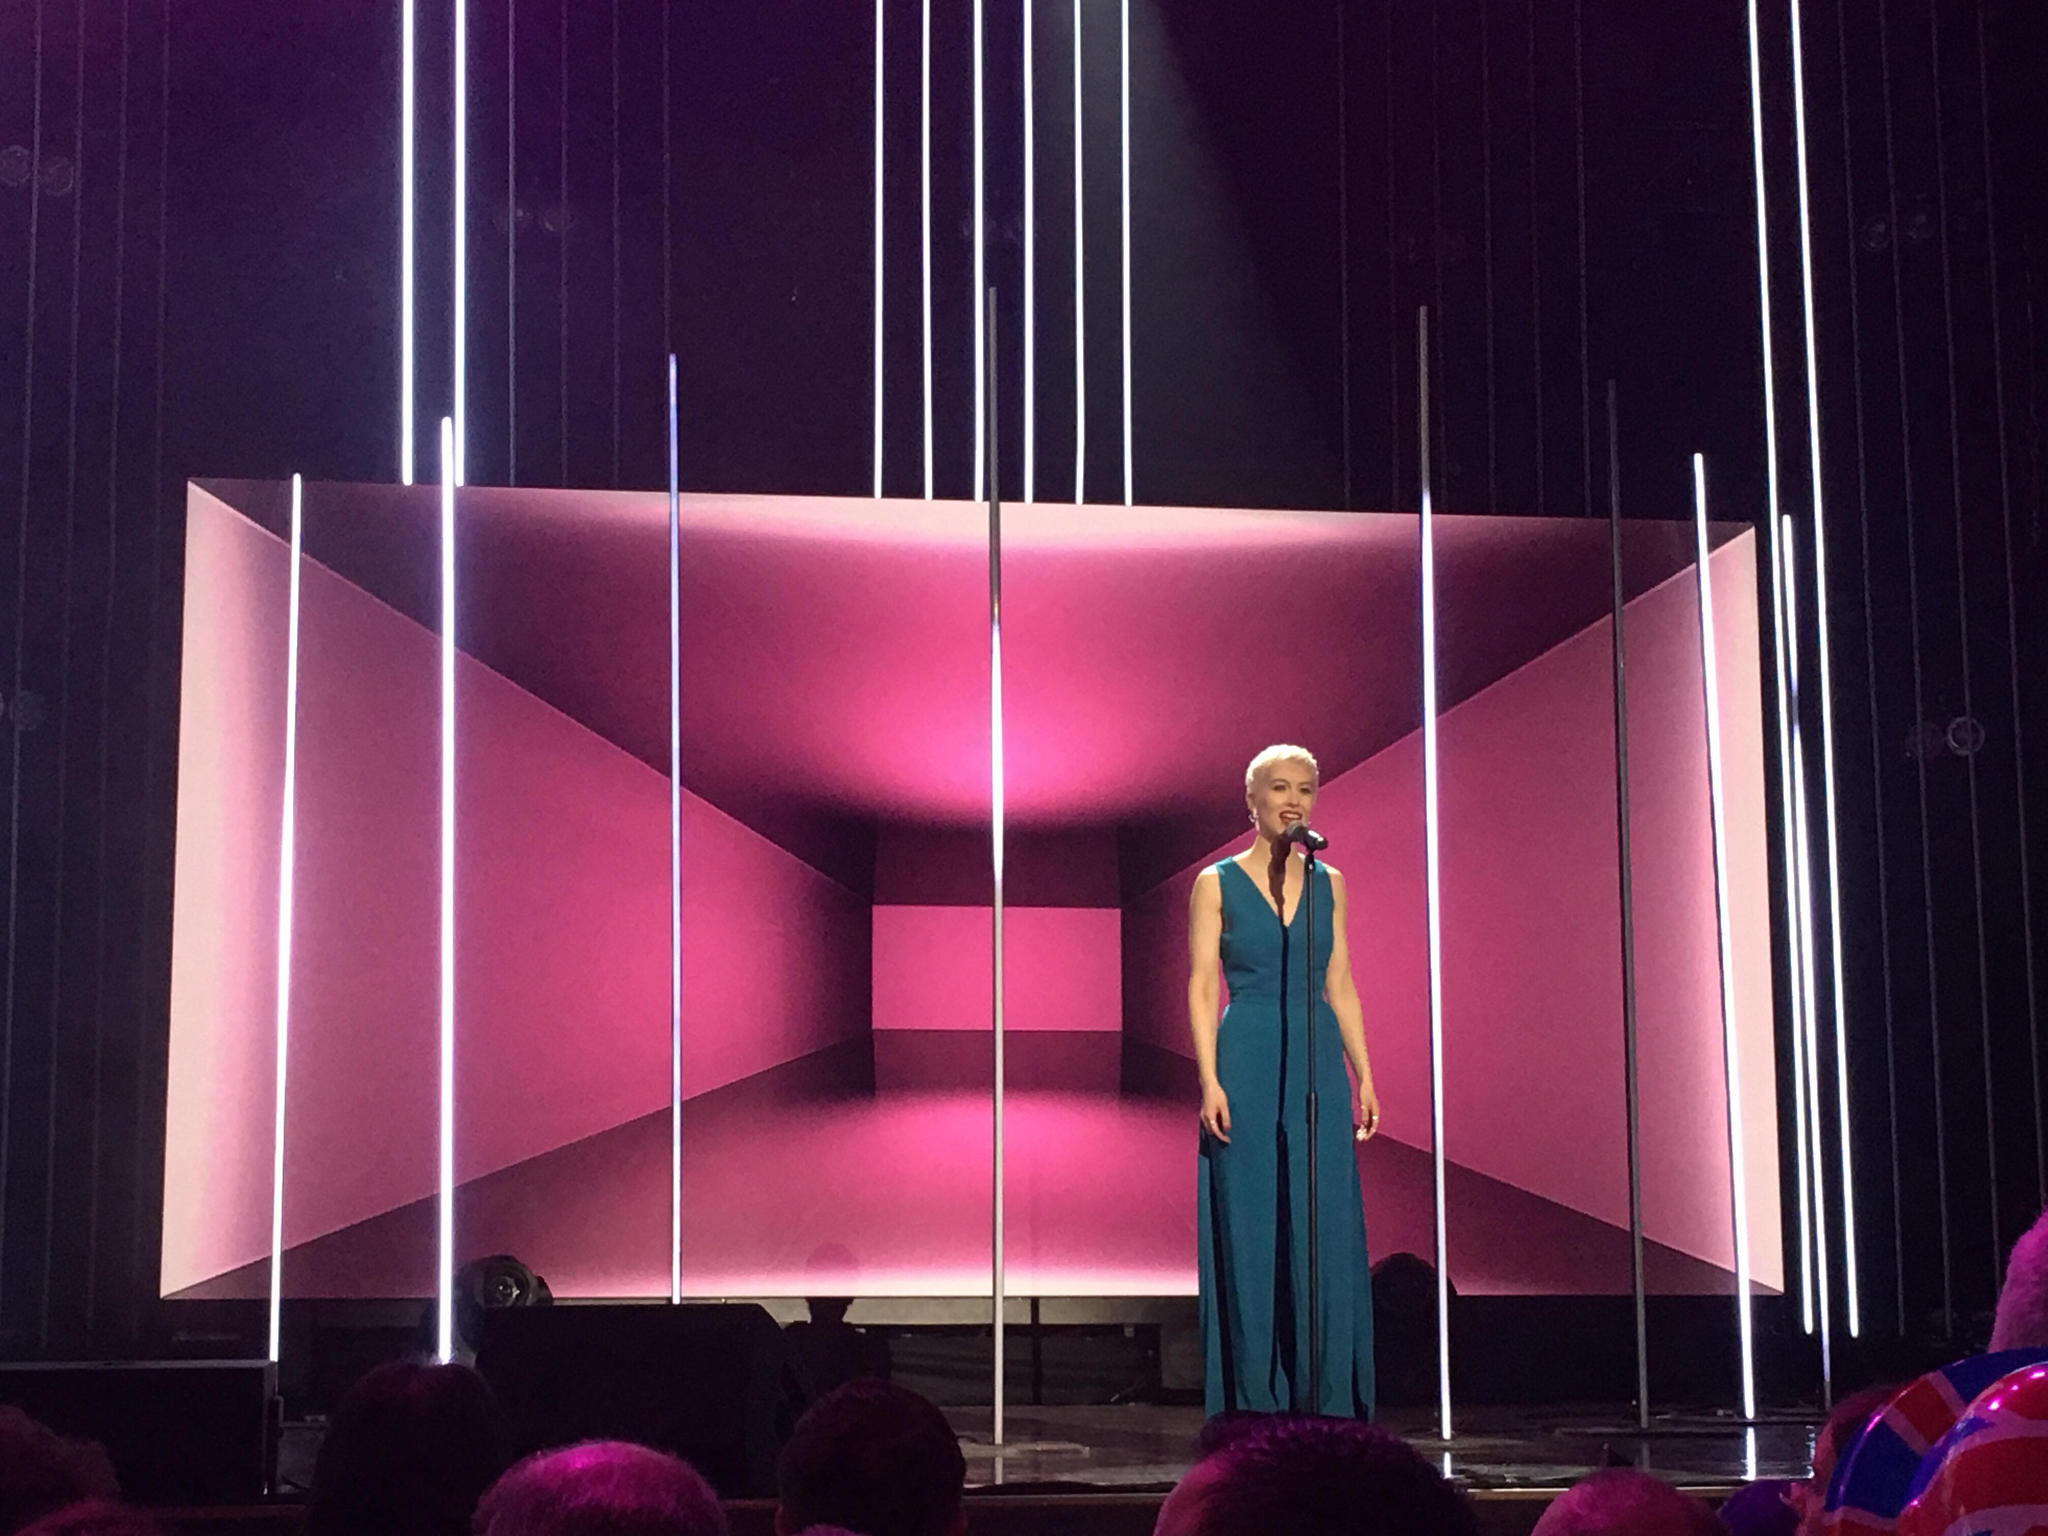Could the vertical white lights imply something about the theme of the performance? Indeed, the vertical white lights might symbolize clarity, truth, or direction, leading the audience's attention upwards and potentially reflecting the underlying message or journey of the performance. They could imply a narrative of aspiration, growth, or an exploration of ideas that transcend the ordinary. 